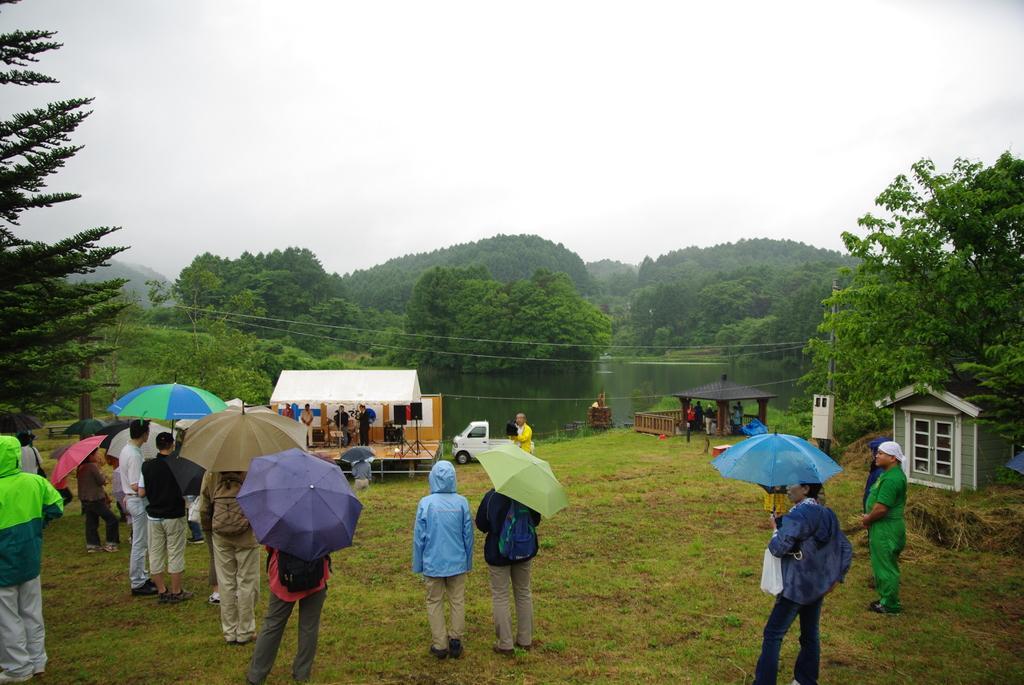How would you summarize this image in a sentence or two? This picture few people standing and they are holding umbrellas in their hands and we see trees, water and a cloudy sky and we see a small truck and few people standing on the Dais and we see tent and grass on the ground and a small house on the side. 